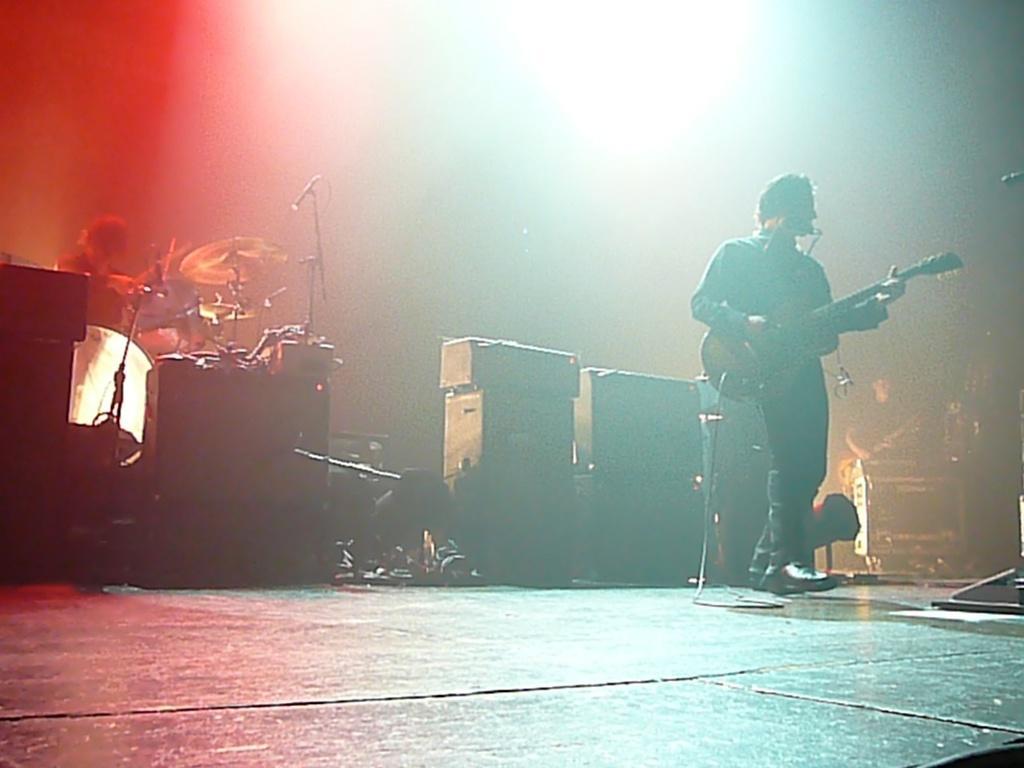How would you summarize this image in a sentence or two? This image is clicked in a concert. A person is standing right side. He is playing guitar. He is also singing. There is a mic in front of him. There are speakers in the middle of the image. On the left side there is person standing who is playing drums and he also has mic over there on the right side corner there is a person he might be standing and playing some musical instrument 